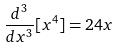<formula> <loc_0><loc_0><loc_500><loc_500>\frac { d ^ { 3 } } { d x ^ { 3 } } [ x ^ { 4 } ] = 2 4 x</formula> 